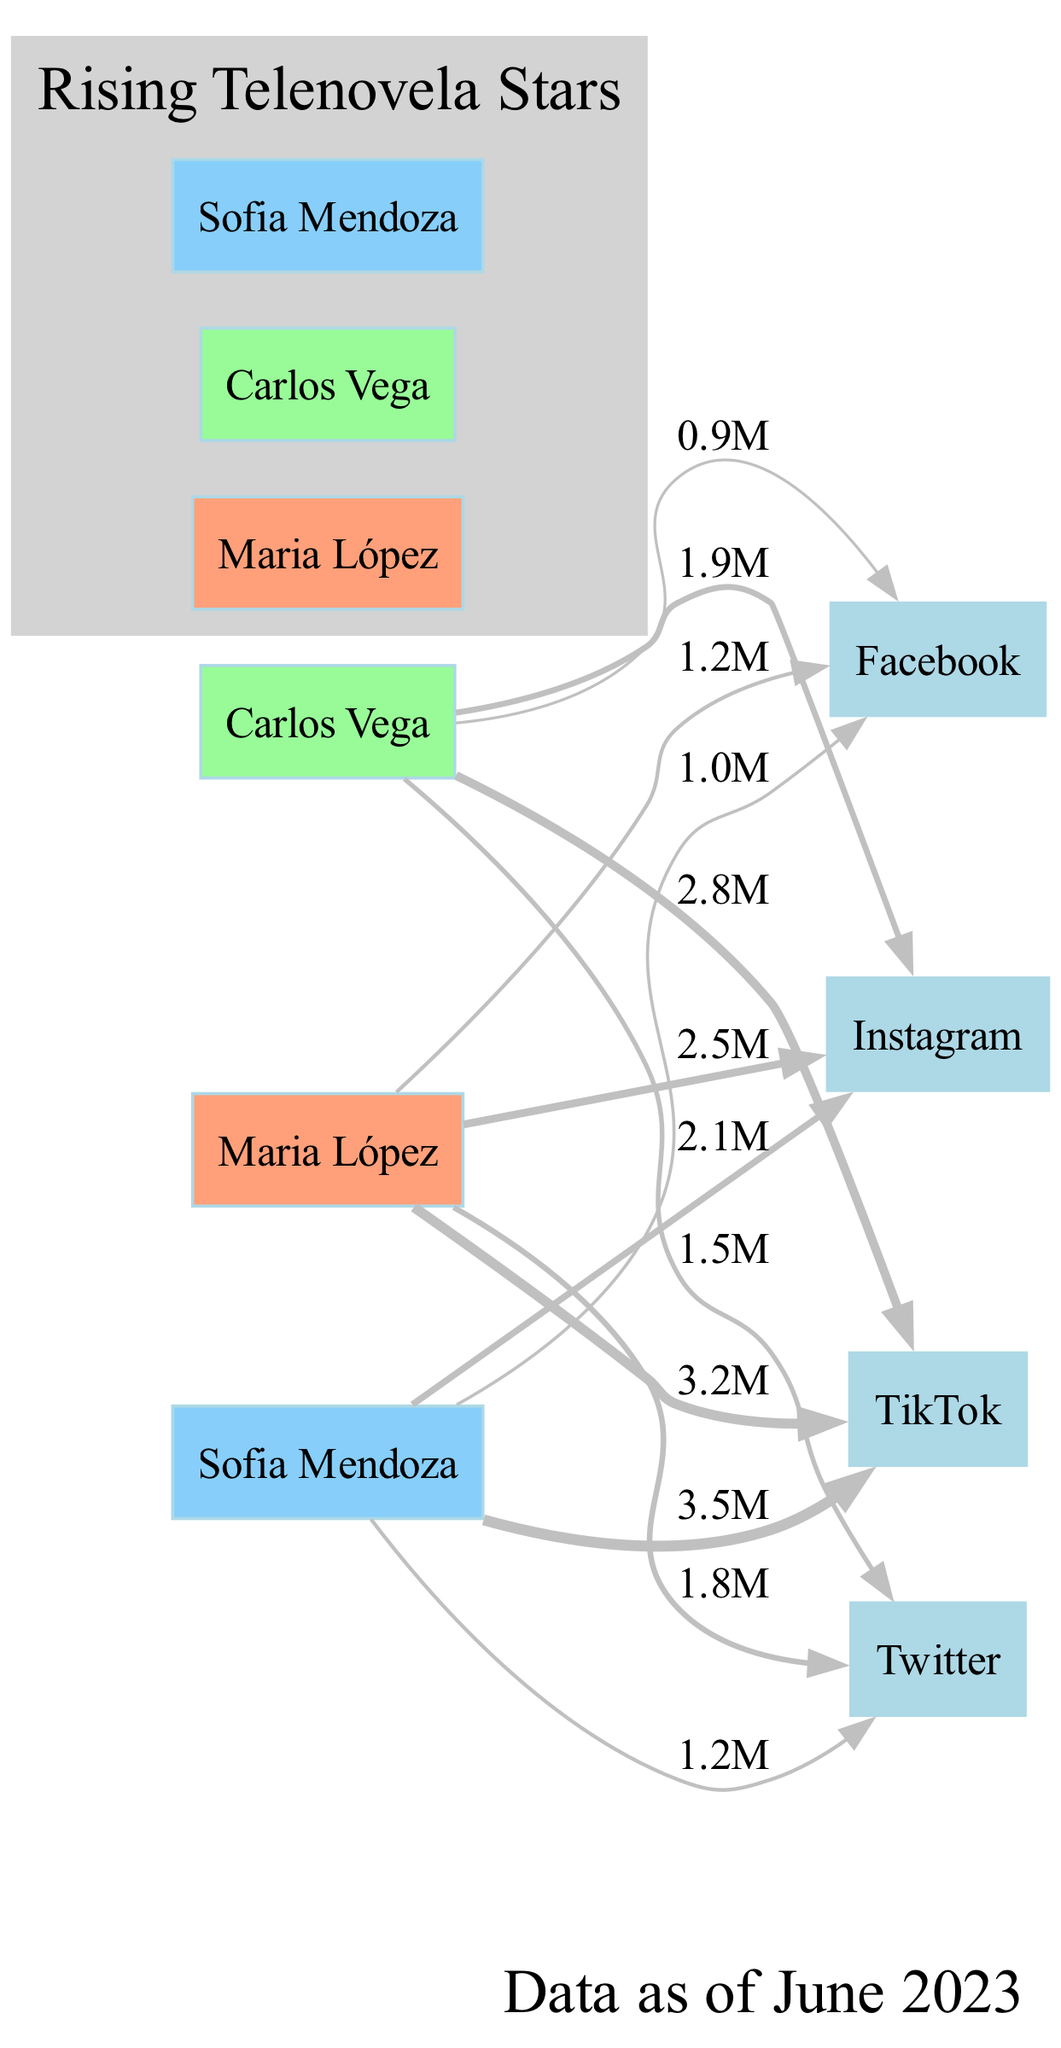What is the highest follower count for Maria López on Instagram? The diagram shows that Maria López has 2.5 million followers on Instagram, which is represented by the length of the bar for that platform connected to her name.
Answer: 2.5 million Which platform does Sofia Mendoza have the most followers? By comparing the follower counts for each platform, Sofia Mendoza has the highest followers on TikTok with 3.5 million, which is indicated by the longest bar under TikTok for her name.
Answer: TikTok How many followers does Carlos Vega have on Facebook? From the diagram, the number of followers Carlos Vega has on Facebook is represented as 0.9 million, visible under the Facebook bar connected to his name.
Answer: 0.9 million Who has the least number of followers on Twitter? Looking at the Twitter follower counts, Carlos Vega has the least with 1.5 million followers, as indicated by the lowest bar for Twitter among the three stars.
Answer: Carlos Vega Which rising star has the most overall followers across all platforms? To determine this, we add up the followers for each rising star. Maria López has a total of 9.7 million, Sofia Mendoza has 8.8 million, and Carlos Vega has 7.1 million. Maria López has the highest total.
Answer: Maria López What is the total number of platforms represented in the diagram? The diagram includes four platforms which are listed along the x-axis: Instagram, TikTok, Twitter, and Facebook. Counting these gives a total of four platforms.
Answer: 4 How many nodes are there for the rising telenovela stars in the diagram? The three stars: Maria López, Carlos Vega, and Sofia Mendoza each represent a node in the diagram. Therefore, there are three nodes corresponding to the rising stars.
Answer: 3 Which platform has the lowest overall follower count among the three stars? By examining each star's count under each platform, Facebook has the lowest overall counts, particularly with Carlos Vega at 0.9 million, highlighting it as the lowest platform.
Answer: Facebook 